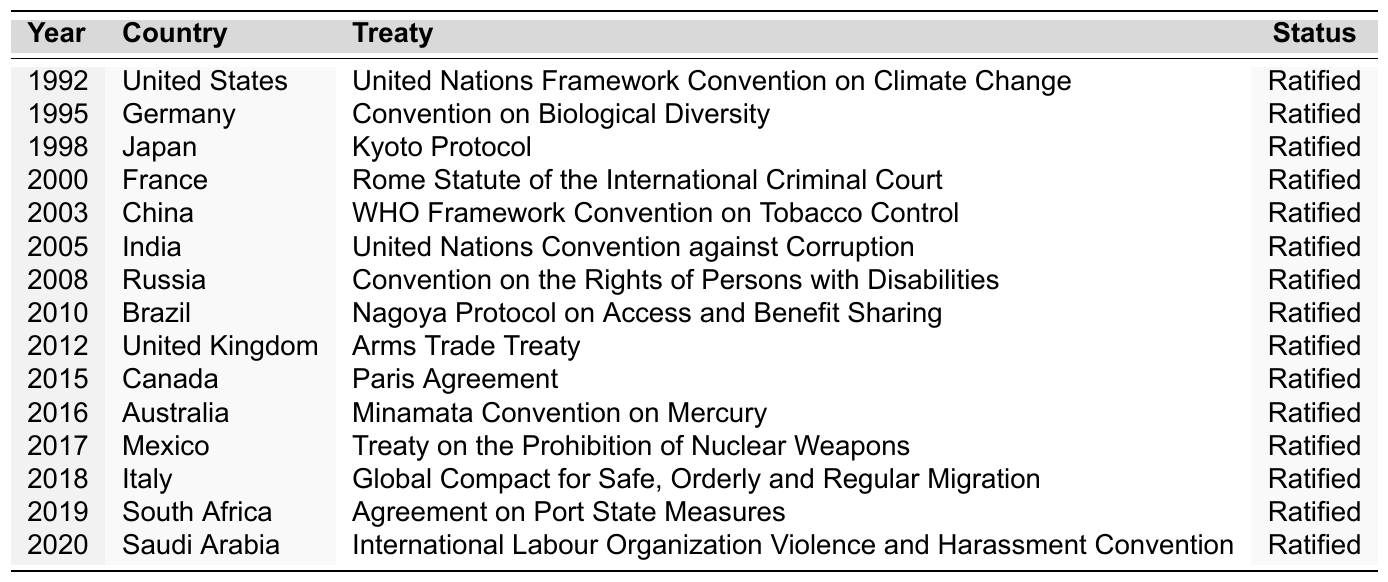What is the most recent treaty ratified by a G20 nation according to the table? The table presents data until the year 2020. The last entry lists Saudi Arabia ratifying the "International Labour Organization Violence and Harassment Convention" in 2020, which is the most recent ratification.
Answer: International Labour Organization Violence and Harassment Convention How many treaties were ratified by the United States since 1990? By scanning the table, I find that the United States ratified one treaty, the "United Nations Framework Convention on Climate Change," in 1992.
Answer: 1 Which country ratified the "Kyoto Protocol"? Looking at the table, Japan is the country that ratified the "Kyoto Protocol" in 1998.
Answer: Japan In which year did France ratify the Rome Statute of the International Criminal Court? According to the table, France ratified the "Rome Statute of the International Criminal Court" in the year 2000.
Answer: 2000 How many countries ratified treaties in the 2010s (2010-2019)? Counting the entries from 2010 to 2019, I find that there are a total of six countries: Brazil, the United Kingdom, Canada, Australia, Mexico, Italy, and South Africa.
Answer: 6 What is the total number of treaties ratified by G20 nations from 1990 to 2020? Upon reviewing the table, I see that there are a total of fifteen entries, indicating fifteen ratified treaties by G20 nations between 1990 and 2020.
Answer: 15 Which country ratified a treaty in 2018 and what was the treaty? The table indicates that in 2018, Italy ratified the "Global Compact for Safe, Orderly and Regular Migration."
Answer: Italy, Global Compact for Safe, Orderly and Regular Migration Did any country ratify more than one treaty during this period? From the data in the table, each G20 country listed ratified only one treaty since 1990, which means no country ratified more than one.
Answer: No Identify the treaty that was ratified by Mexico in 2017. According to the entry for Mexico in the table, the treaty ratified was the "Treaty on the Prohibition of Nuclear Weapons."
Answer: Treaty on the Prohibition of Nuclear Weapons Which is the only treaty ratified by India according to the data? By examining the table, I find that India's sole ratified treaty is the "United Nations Convention against Corruption" in 2005.
Answer: United Nations Convention against Corruption 